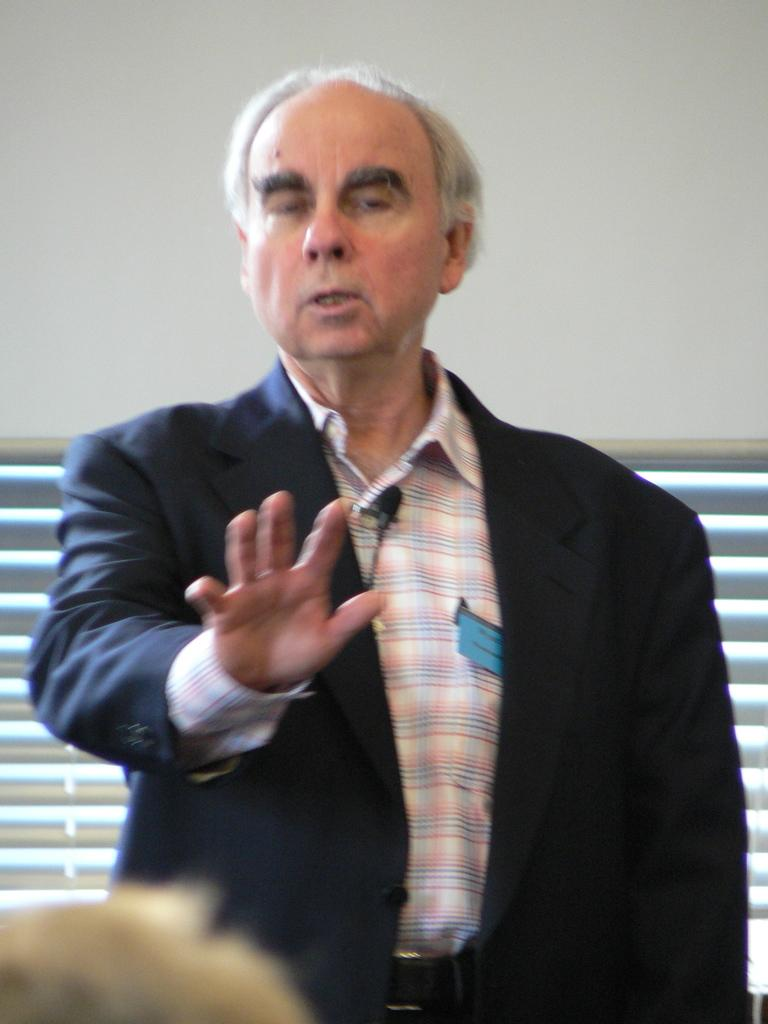What is the main subject of the image? The main subject of the image is a man. Can you describe the man's position in the image? The man is in the center of the image. What type of book is the man smashing with ink in the image? There is no book, smashing, or ink present in the image; it only features a man in the center. 